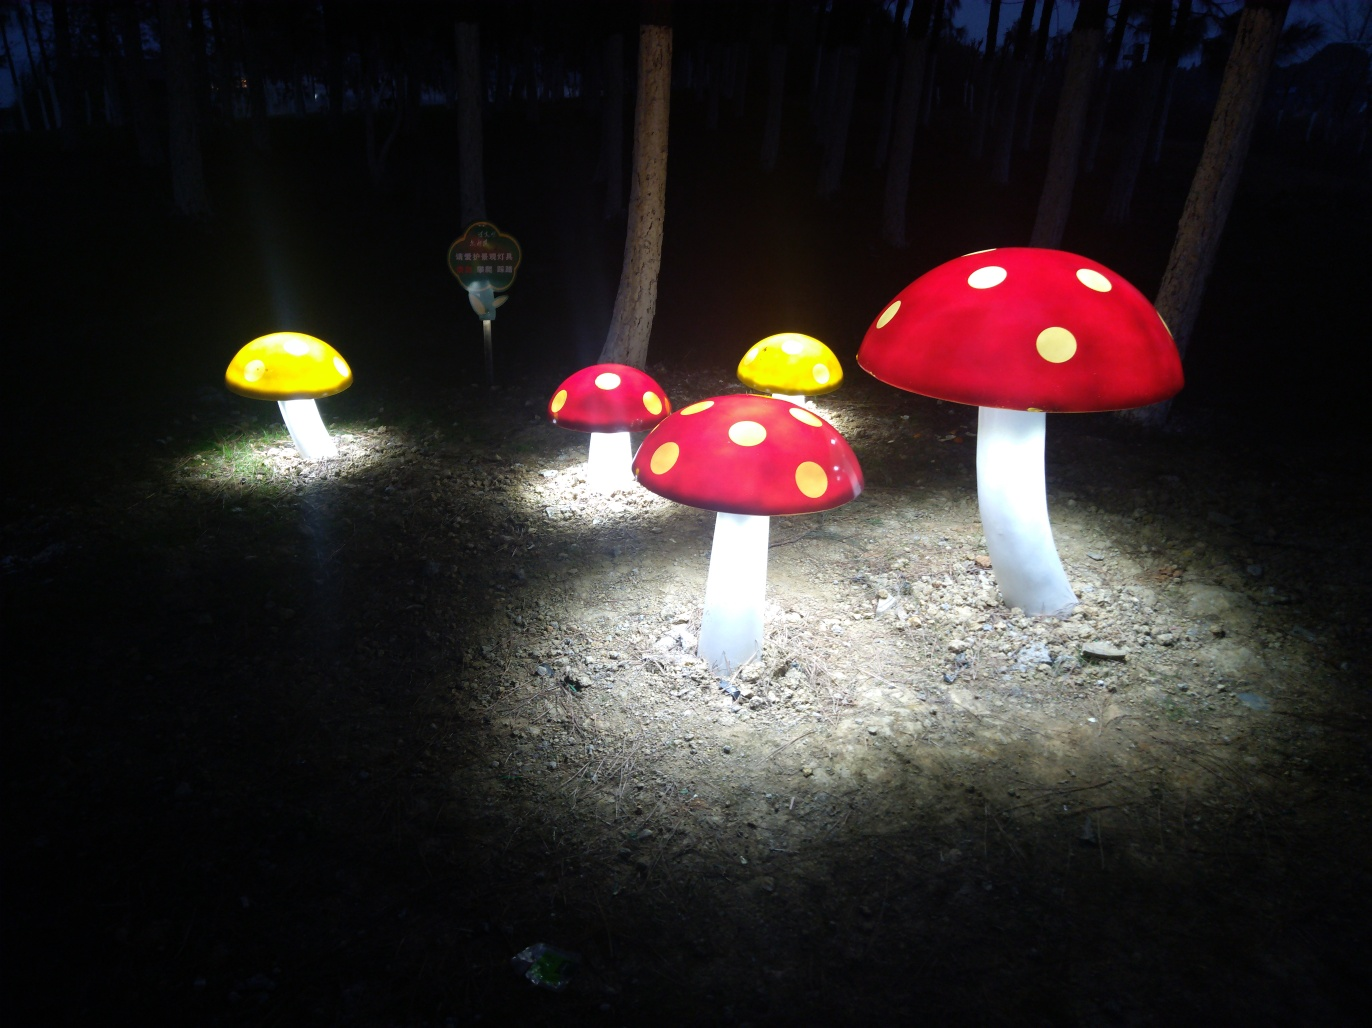Are there any focusing issues in this image?
A. Yes
B. Sometimes
C. No
D. Occasionally
Answer with the option's letter from the given choices directly.
 C. 